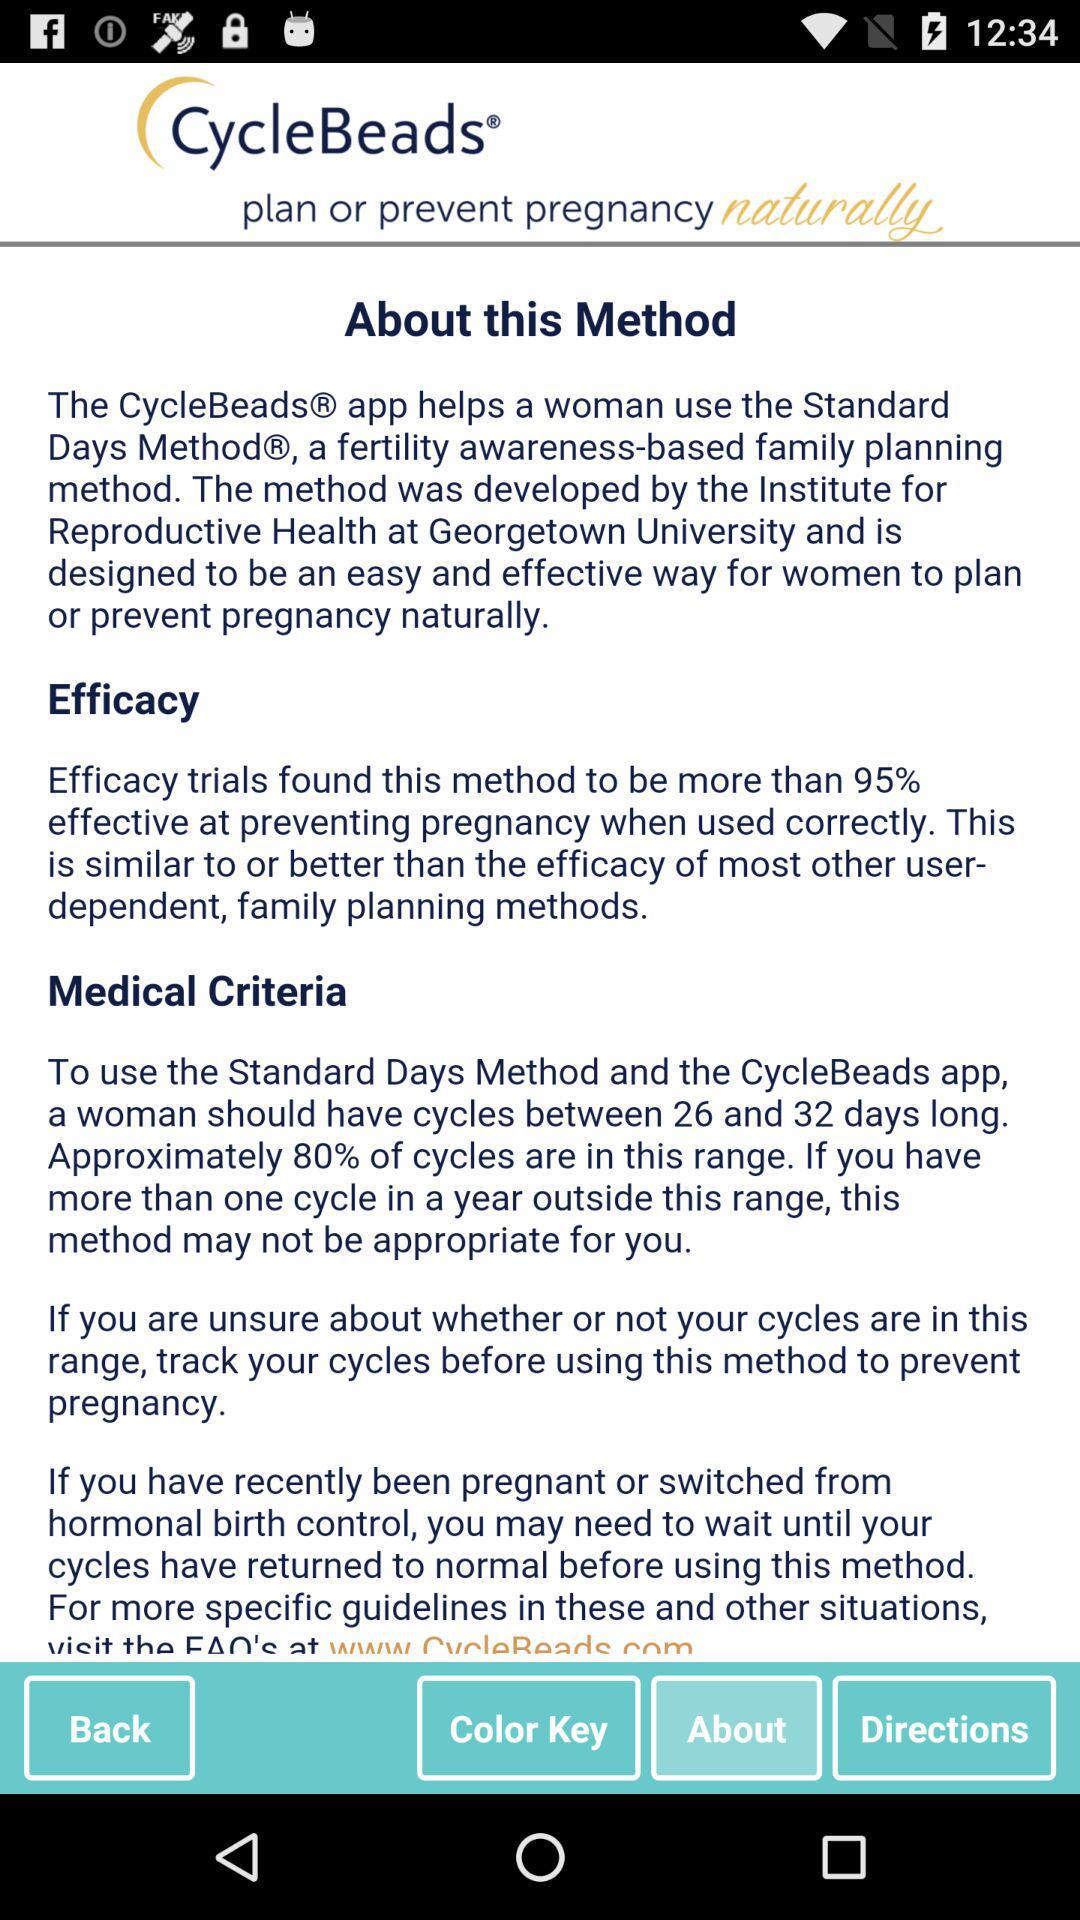How many days longer is the longest cycle than the shortest cycle?
Answer the question using a single word or phrase. 6 